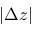Convert formula to latex. <formula><loc_0><loc_0><loc_500><loc_500>| \Delta z |</formula> 